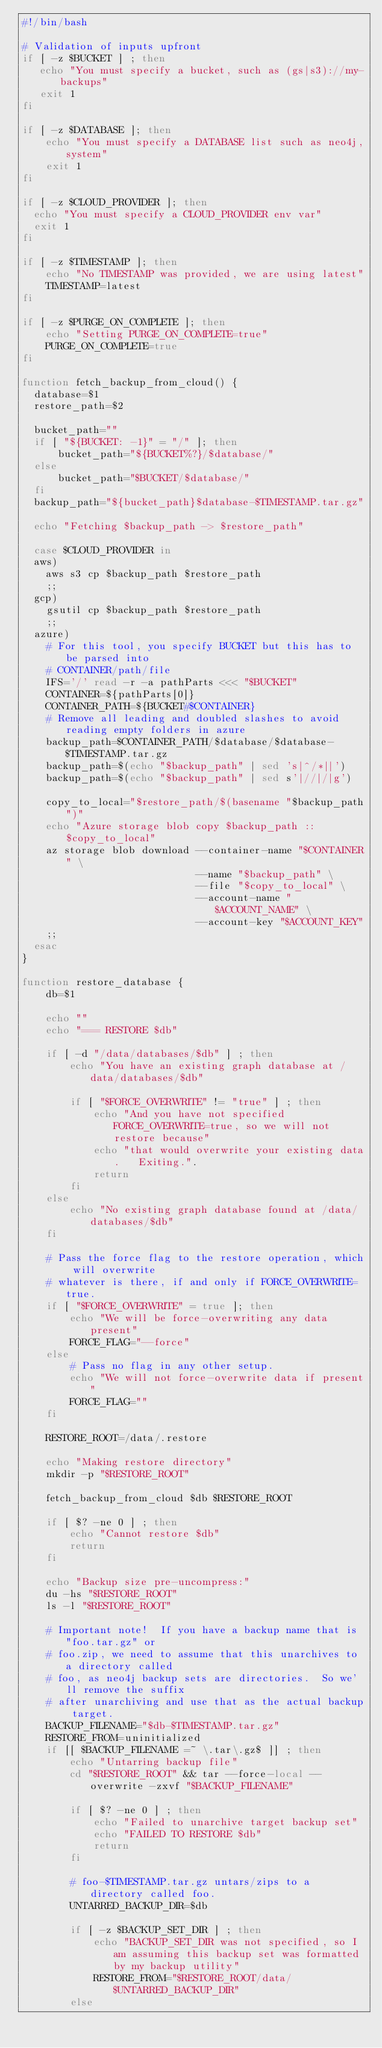<code> <loc_0><loc_0><loc_500><loc_500><_Bash_>#!/bin/bash

# Validation of inputs upfront
if [ -z $BUCKET ] ; then
   echo "You must specify a bucket, such as (gs|s3)://my-backups"
   exit 1
fi

if [ -z $DATABASE ]; then
    echo "You must specify a DATABASE list such as neo4j,system"
    exit 1
fi

if [ -z $CLOUD_PROVIDER ]; then
  echo "You must specify a CLOUD_PROVIDER env var"
  exit 1
fi

if [ -z $TIMESTAMP ]; then
    echo "No TIMESTAMP was provided, we are using latest"
    TIMESTAMP=latest
fi

if [ -z $PURGE_ON_COMPLETE ]; then
    echo "Setting PURGE_ON_COMPLETE=true"
    PURGE_ON_COMPLETE=true
fi

function fetch_backup_from_cloud() {
  database=$1
  restore_path=$2

  bucket_path=""
  if [ "${BUCKET: -1}" = "/" ]; then
      bucket_path="${BUCKET%?}/$database/"
  else
      bucket_path="$BUCKET/$database/"
  fi
  backup_path="${bucket_path}$database-$TIMESTAMP.tar.gz"

  echo "Fetching $backup_path -> $restore_path"

  case $CLOUD_PROVIDER in
  aws)
    aws s3 cp $backup_path $restore_path
    ;;
  gcp)
    gsutil cp $backup_path $restore_path
    ;;
  azure)
    # For this tool, you specify BUCKET but this has to be parsed into 
    # CONTAINER/path/file
    IFS='/' read -r -a pathParts <<< "$BUCKET"
    CONTAINER=${pathParts[0]}
    CONTAINER_PATH=${BUCKET#$CONTAINER}
    # Remove all leading and doubled slashes to avoid reading empty folders in azure
    backup_path=$CONTAINER_PATH/$database/$database-$TIMESTAMP.tar.gz    
    backup_path=$(echo "$backup_path" | sed 's|^/*||')
    backup_path=$(echo "$backup_path" | sed s'|//|/|g')

    copy_to_local="$restore_path/$(basename "$backup_path")"
    echo "Azure storage blob copy $backup_path :: $copy_to_local"
    az storage blob download --container-name "$CONTAINER" \
                             --name "$backup_path" \
                             --file "$copy_to_local" \
                             --account-name "$ACCOUNT_NAME" \
                             --account-key "$ACCOUNT_KEY"
    ;;
  esac
}

function restore_database {
    db=$1

    echo ""
    echo "=== RESTORE $db"

    if [ -d "/data/databases/$db" ] ; then
        echo "You have an existing graph database at /data/databases/$db"

        if [ "$FORCE_OVERWRITE" != "true" ] ; then
            echo "And you have not specified FORCE_OVERWRITE=true, so we will not restore because"
            echo "that would overwrite your existing data.   Exiting.".
            return
        fi
    else 
        echo "No existing graph database found at /data/databases/$db"
    fi

    # Pass the force flag to the restore operation, which will overwrite
    # whatever is there, if and only if FORCE_OVERWRITE=true.
    if [ "$FORCE_OVERWRITE" = true ]; then
        echo "We will be force-overwriting any data present"
        FORCE_FLAG="--force"
    else
        # Pass no flag in any other setup.
        echo "We will not force-overwrite data if present"
        FORCE_FLAG=""
    fi

    RESTORE_ROOT=/data/.restore

    echo "Making restore directory"
    mkdir -p "$RESTORE_ROOT"

    fetch_backup_from_cloud $db $RESTORE_ROOT

    if [ $? -ne 0 ] ; then
        echo "Cannot restore $db"
        return
    fi

    echo "Backup size pre-uncompress:"
    du -hs "$RESTORE_ROOT"
    ls -l "$RESTORE_ROOT"

    # Important note!  If you have a backup name that is "foo.tar.gz" or 
    # foo.zip, we need to assume that this unarchives to a directory called
    # foo, as neo4j backup sets are directories.  So we'll remove the suffix
    # after unarchiving and use that as the actual backup target.
    BACKUP_FILENAME="$db-$TIMESTAMP.tar.gz"
    RESTORE_FROM=uninitialized
    if [[ $BACKUP_FILENAME =~ \.tar\.gz$ ]] ; then
        echo "Untarring backup file"
        cd "$RESTORE_ROOT" && tar --force-local --overwrite -zxvf "$BACKUP_FILENAME"

        if [ $? -ne 0 ] ; then
            echo "Failed to unarchive target backup set"
            echo "FAILED TO RESTORE $db"
            return
        fi

        # foo-$TIMESTAMP.tar.gz untars/zips to a directory called foo.
        UNTARRED_BACKUP_DIR=$db

        if [ -z $BACKUP_SET_DIR ] ; then
            echo "BACKUP_SET_DIR was not specified, so I am assuming this backup set was formatted by my backup utility"
            RESTORE_FROM="$RESTORE_ROOT/data/$UNTARRED_BACKUP_DIR"
        else </code> 